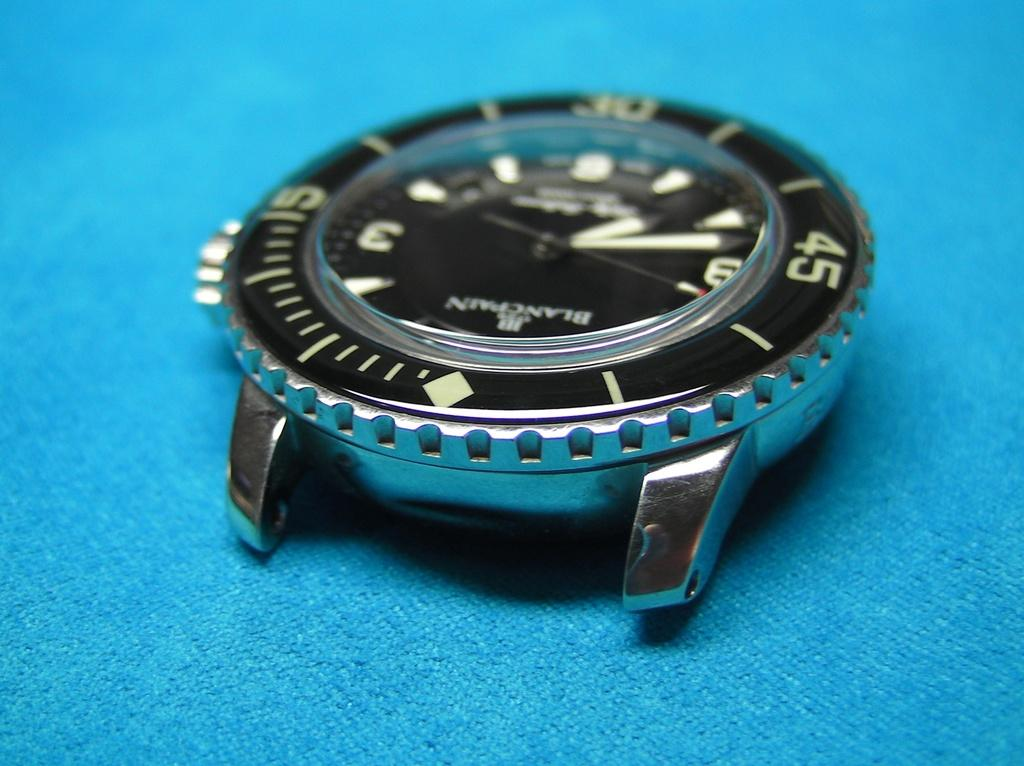<image>
Give a short and clear explanation of the subsequent image. the number 45 that is on a watch 